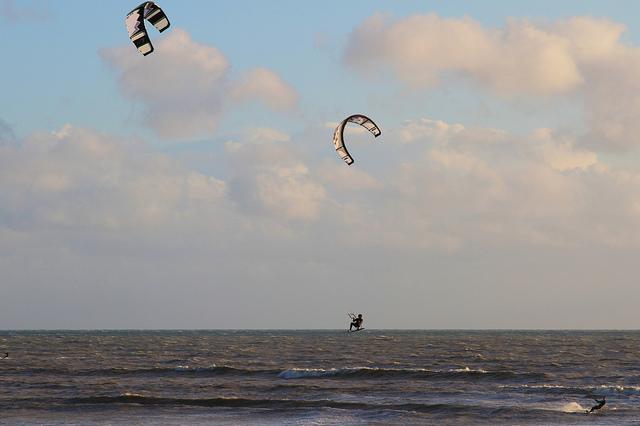What sport is shown?
Keep it brief. Parasailing. Is it a sunny day?
Keep it brief. No. Is the wind blowing from left to right or right to left?
Answer briefly. Right to left. What is under the man's feet?
Concise answer only. Surfboard. How many kites can be seen?
Quick response, please. 2. How many kites are flying?
Be succinct. 2. How many people are in this photo?
Answer briefly. 2. 